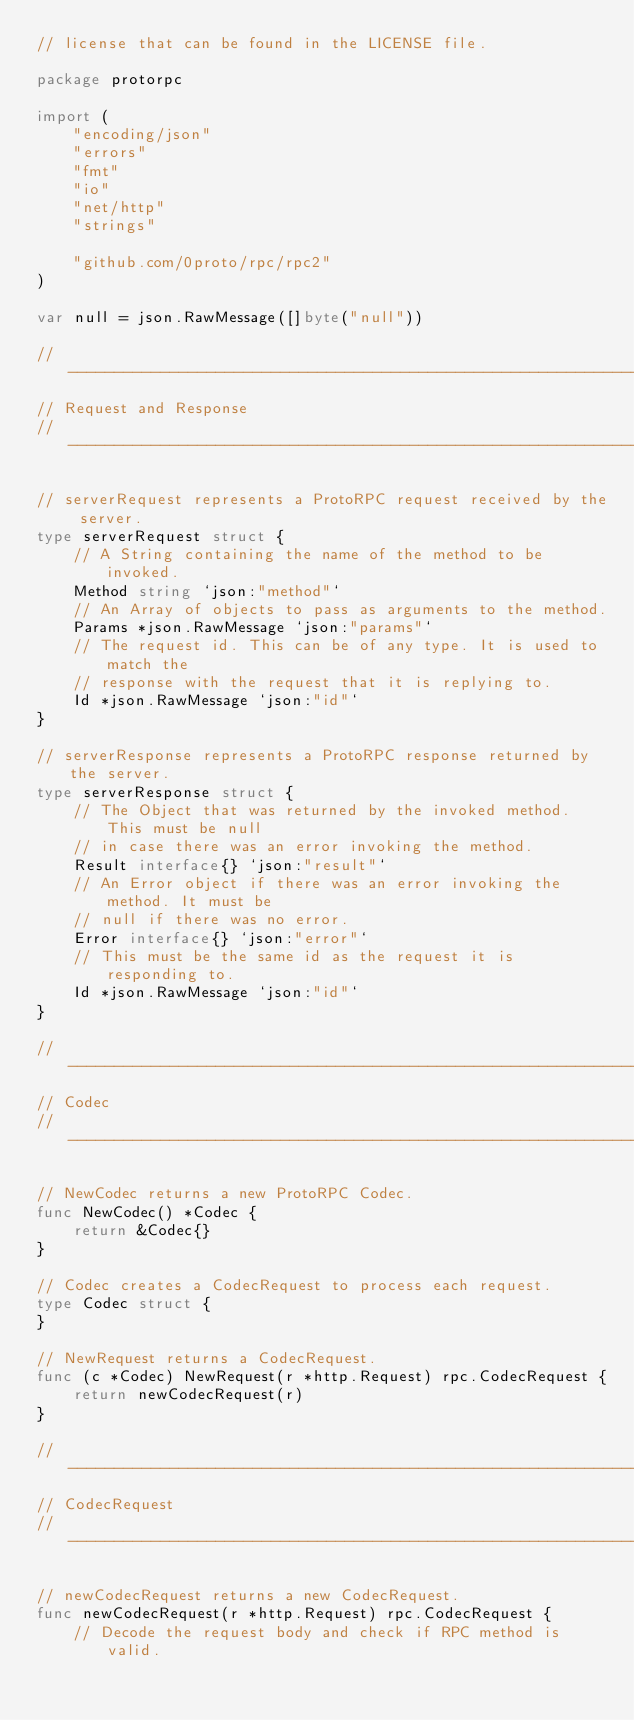<code> <loc_0><loc_0><loc_500><loc_500><_Go_>// license that can be found in the LICENSE file.

package protorpc

import (
	"encoding/json"
	"errors"
	"fmt"
	"io"
	"net/http"
	"strings"

	"github.com/0proto/rpc/rpc2"
)

var null = json.RawMessage([]byte("null"))

// ----------------------------------------------------------------------------
// Request and Response
// ----------------------------------------------------------------------------

// serverRequest represents a ProtoRPC request received by the server.
type serverRequest struct {
	// A String containing the name of the method to be invoked.
	Method string `json:"method"`
	// An Array of objects to pass as arguments to the method.
	Params *json.RawMessage `json:"params"`
	// The request id. This can be of any type. It is used to match the
	// response with the request that it is replying to.
	Id *json.RawMessage `json:"id"`
}

// serverResponse represents a ProtoRPC response returned by the server.
type serverResponse struct {
	// The Object that was returned by the invoked method. This must be null
	// in case there was an error invoking the method.
	Result interface{} `json:"result"`
	// An Error object if there was an error invoking the method. It must be
	// null if there was no error.
	Error interface{} `json:"error"`
	// This must be the same id as the request it is responding to.
	Id *json.RawMessage `json:"id"`
}

// ----------------------------------------------------------------------------
// Codec
// ----------------------------------------------------------------------------

// NewCodec returns a new ProtoRPC Codec.
func NewCodec() *Codec {
	return &Codec{}
}

// Codec creates a CodecRequest to process each request.
type Codec struct {
}

// NewRequest returns a CodecRequest.
func (c *Codec) NewRequest(r *http.Request) rpc.CodecRequest {
	return newCodecRequest(r)
}

// ----------------------------------------------------------------------------
// CodecRequest
// ----------------------------------------------------------------------------

// newCodecRequest returns a new CodecRequest.
func newCodecRequest(r *http.Request) rpc.CodecRequest {
	// Decode the request body and check if RPC method is valid.</code> 